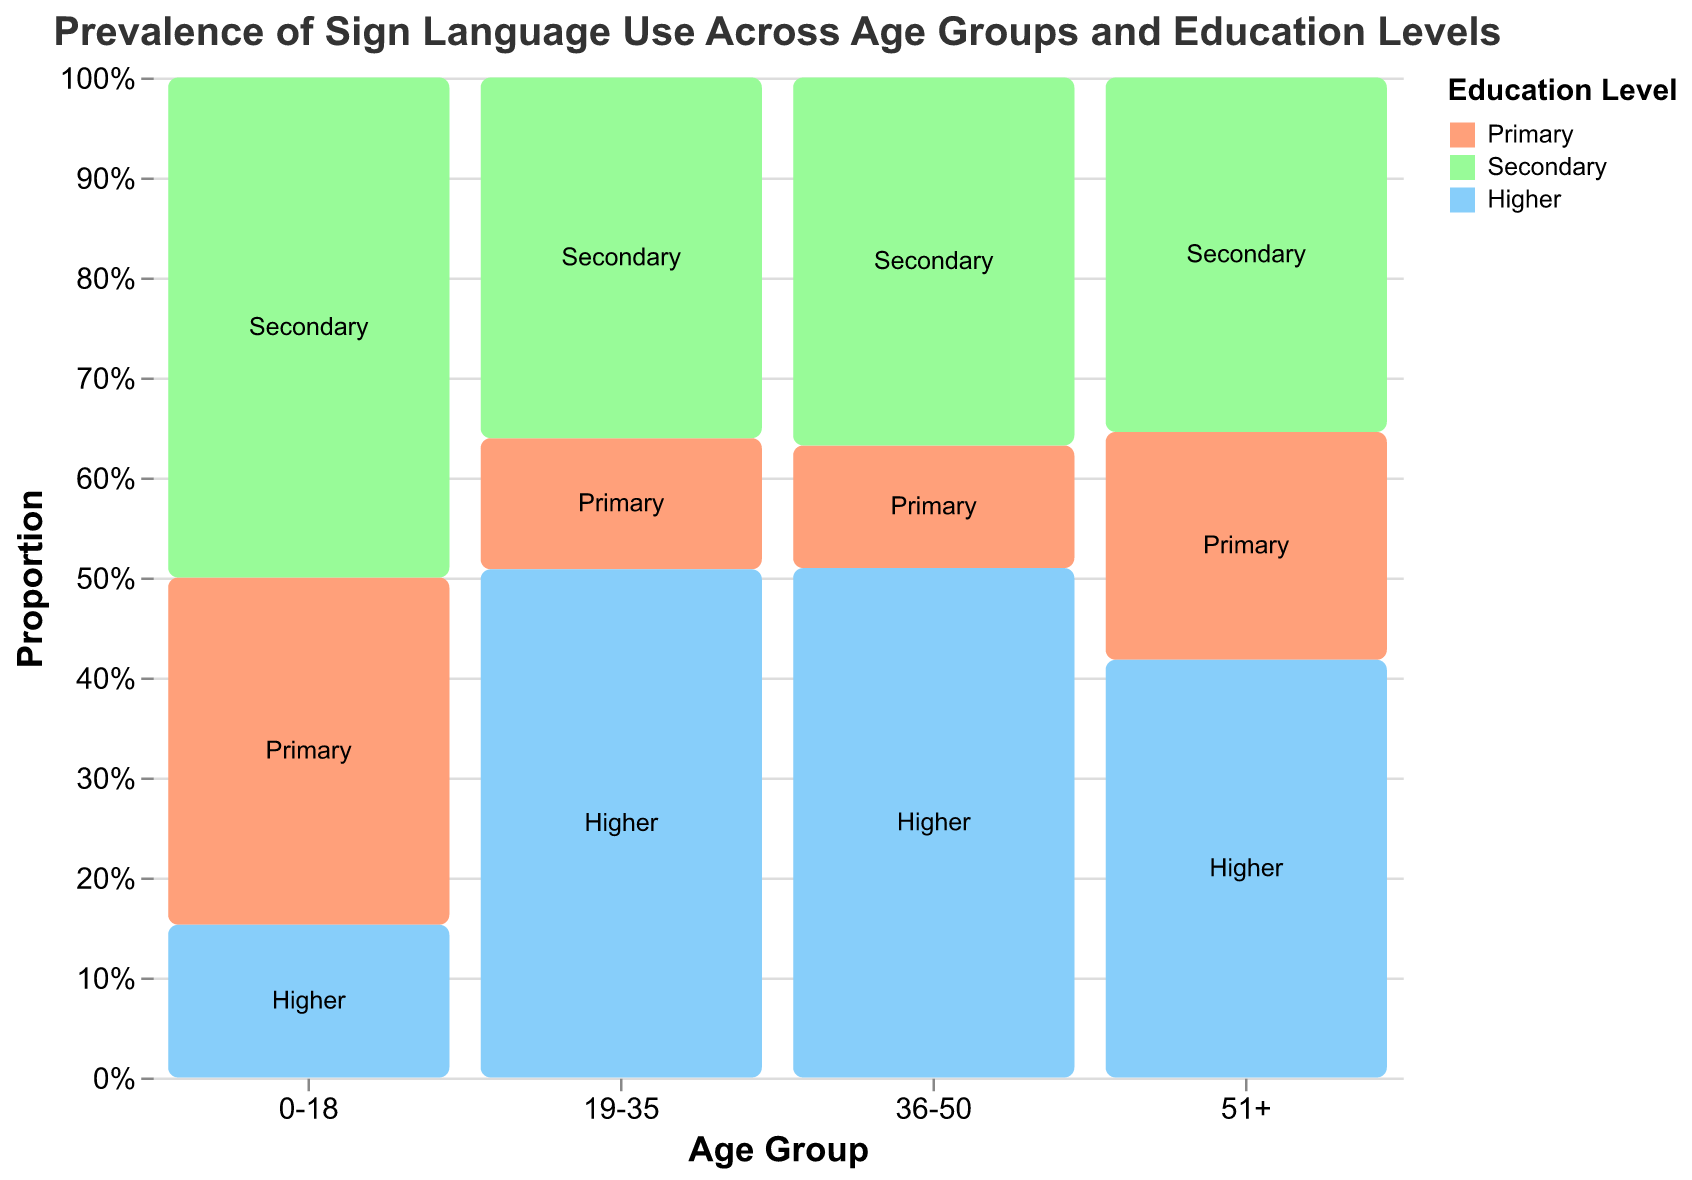What is the title of the plot? The title is usually displayed at the top of the figure. In this case, the title reads "Prevalence of Sign Language Use Across Age Groups and Education Levels."
Answer: Prevalence of Sign Language Use Across Age Groups and Education Levels What are the age groups compared in the plot? The x-axis represents the age groups. According to the data, the age groups compared are "0-18," "19-35," "36-50," and "51+."
Answer: 0-18, 19-35, 36-50, 51+ How is the prevalence of sign language use among primary-level individuals aged 36-50 compared to those aged 51+? To compare the prevalence, look at the width of the segments for "Primary" in the "36-50" and "51+" age groups. The segment for "Primary" in "51+" is wider, indicating higher prevalence among older individuals.
Answer: Higher in 51+ Which education level has the highest proportion of sign language users in the 19-35 age group? Examine the segments within the "19-35" group. The "Higher" education level segment is the largest, indicating it has the highest proportion of sign language users.
Answer: Higher What is the total number of sign language users in the 0-18 age group? Sum the values for all education levels in the 0-18 age group. 12500 (Primary) + 18000 (Secondary) + 5500 (Higher) = 36000.
Answer: 36000 Which age group has the highest proportion of sign language users with higher education? Compare the "Higher" education level segments across all age groups. The "19-35" group has the largest segment, indicating the highest proportion.
Answer: 19-35 What is the difference in sign language use between secondary-level individuals aged 0-18 and 36-50? Compare the secondary-level segments in the "0-18" and "36-50" groups. Calculate the difference: 18000 (0-18) - 19500 (36-50) = -1500.
Answer: -1500 How does the proportion of sign language users with higher education change from the 19-35 to the 51+ age group? Observe the "Higher" education level segments for "19-35" and "51+." The proportion decreases as the segment size is smaller in the 51+ group.
Answer: Decreases Which education levels have the lowest proportion of sign language users in the 51+ age group? Look at the segments within the "51+" group. The "Primary" segment is the smallest, indicating the lowest proportion of sign language users.
Answer: Primary 